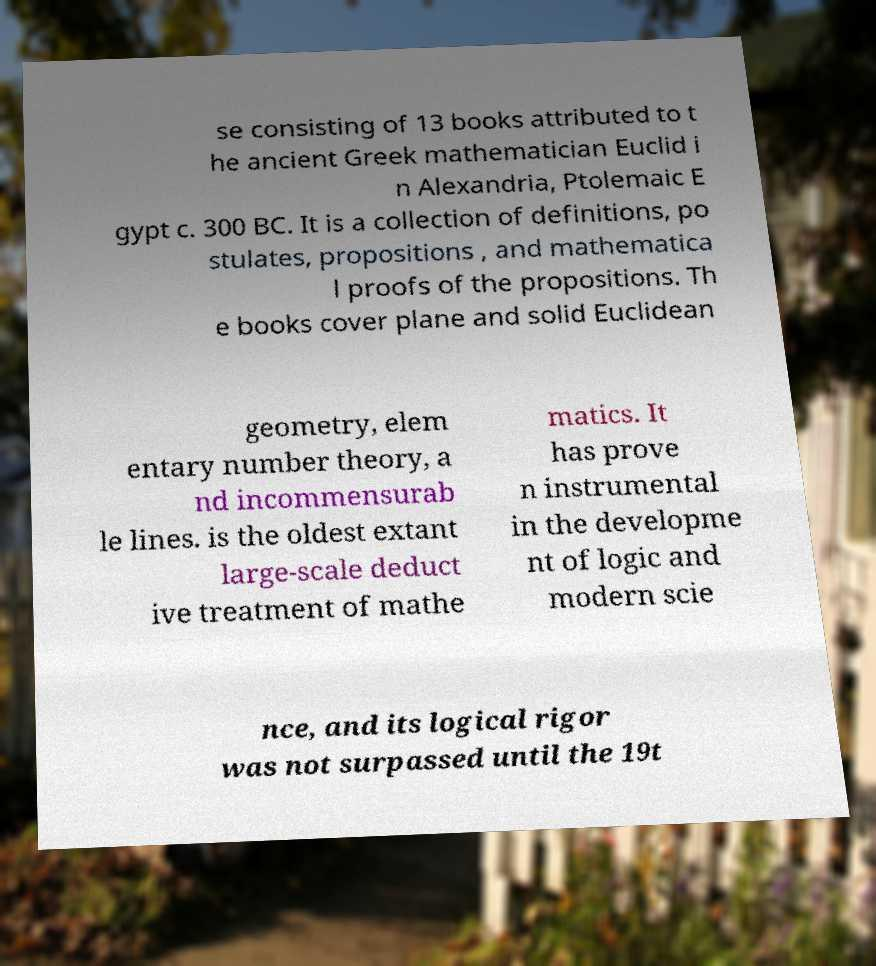There's text embedded in this image that I need extracted. Can you transcribe it verbatim? se consisting of 13 books attributed to t he ancient Greek mathematician Euclid i n Alexandria, Ptolemaic E gypt c. 300 BC. It is a collection of definitions, po stulates, propositions , and mathematica l proofs of the propositions. Th e books cover plane and solid Euclidean geometry, elem entary number theory, a nd incommensurab le lines. is the oldest extant large-scale deduct ive treatment of mathe matics. It has prove n instrumental in the developme nt of logic and modern scie nce, and its logical rigor was not surpassed until the 19t 